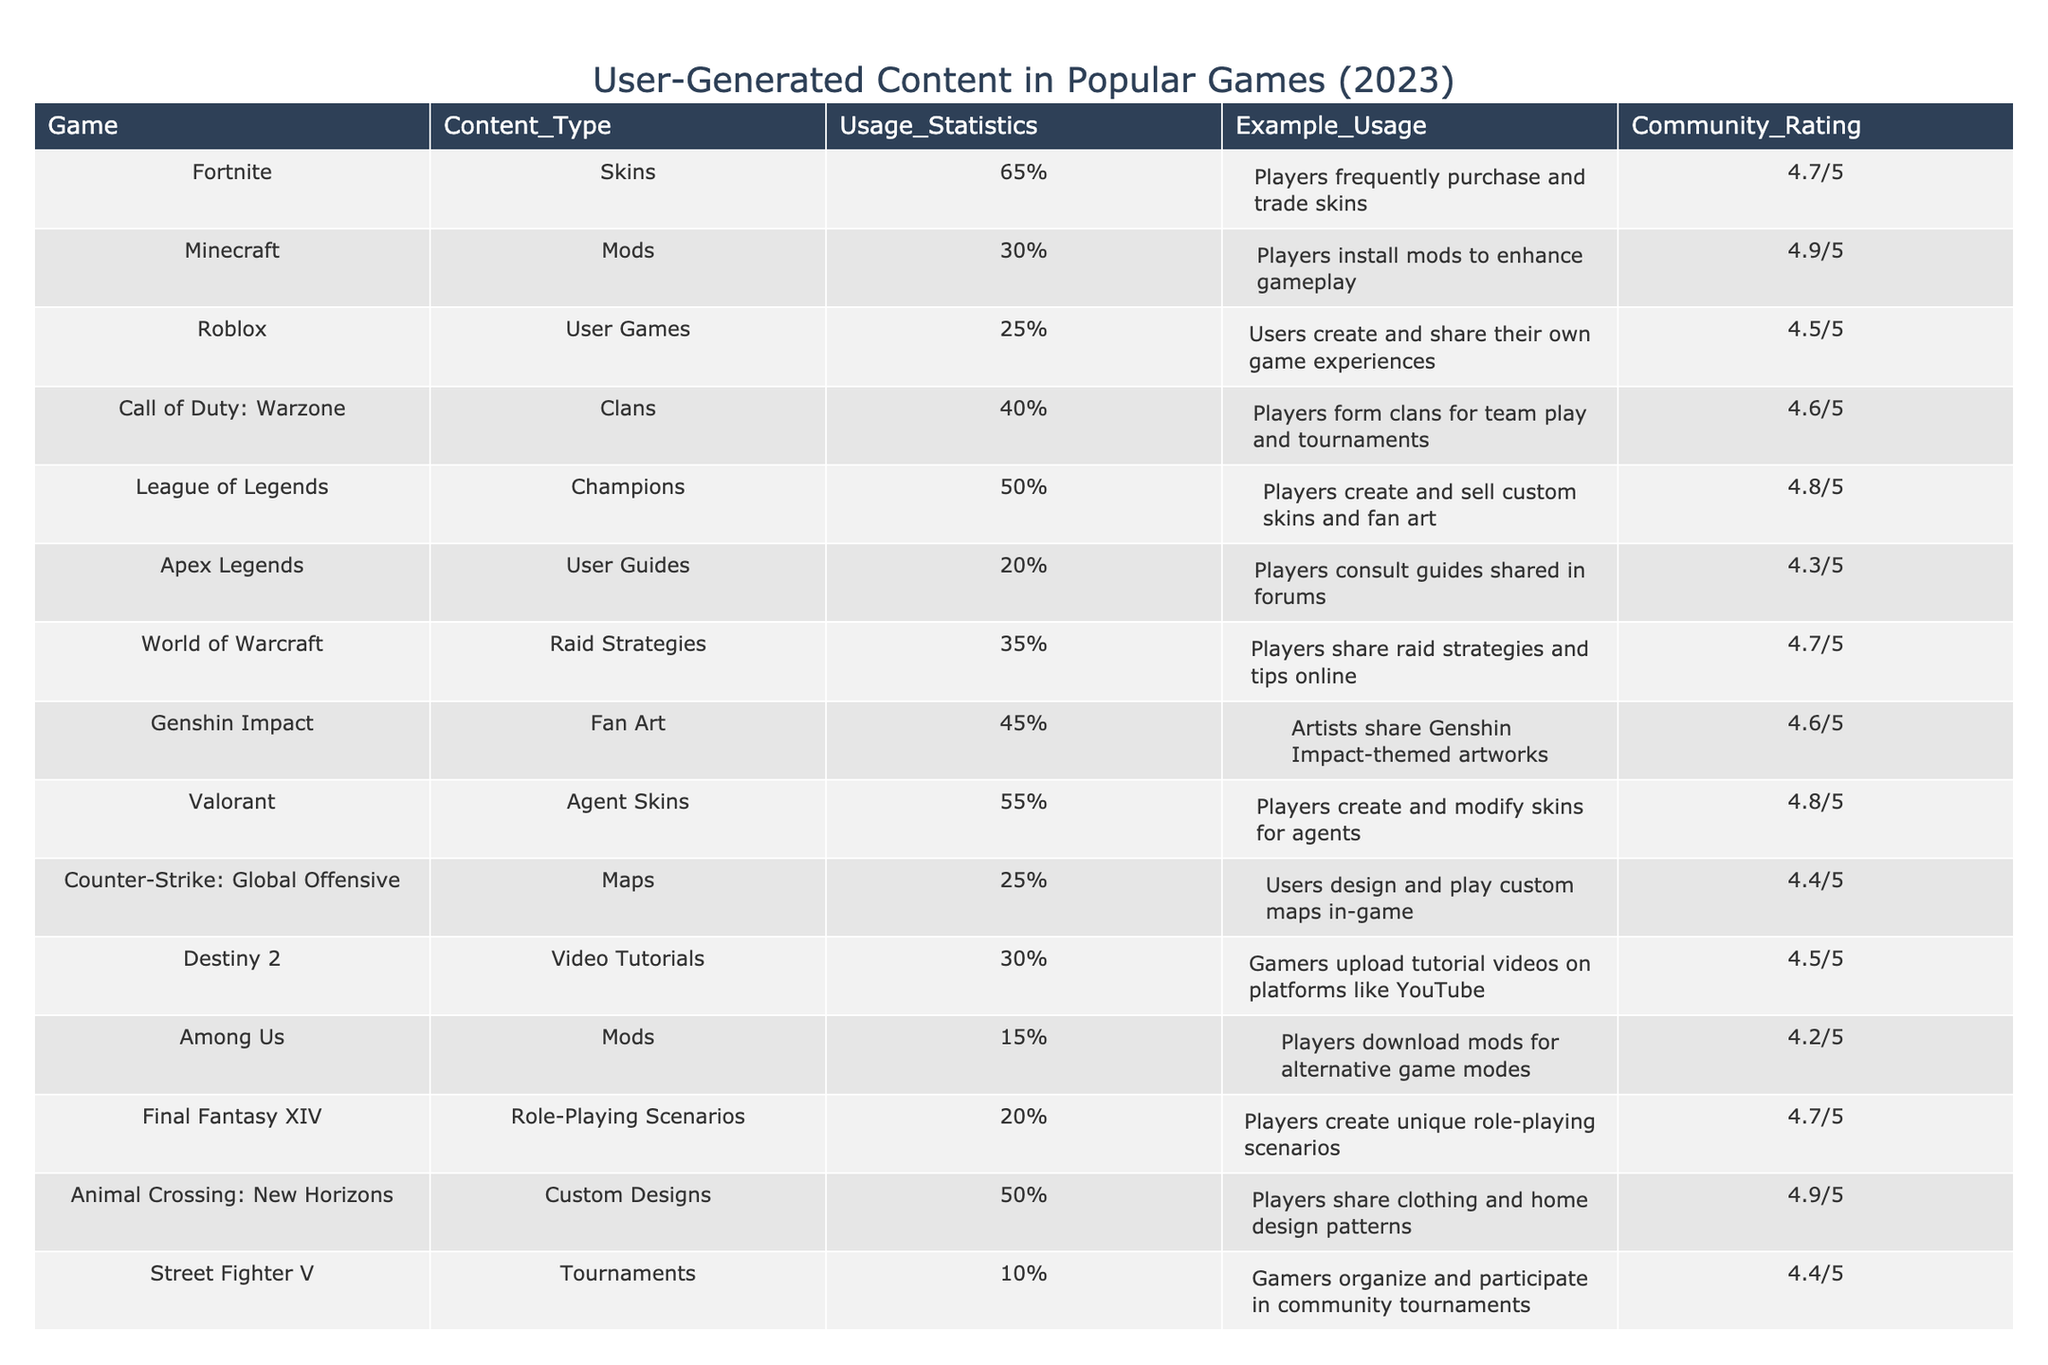What is the community rating for Animal Crossing: New Horizons? The table lists the community rating for Animal Crossing: New Horizons as 4.9/5 in the Community Rating column.
Answer: 4.9/5 Which game has the highest usage statistics for user-generated content? By comparing the Usage Statistics values, Fortnite has the highest usage at 65%.
Answer: Fortnite How many games have a community rating of 4.6 or higher? The community ratings of the games are 4.7, 4.9, 4.5, 4.8, 4.6, 4.7, and 4.4. Counting the ratings, there are 8 games with a rating of 4.6 or higher.
Answer: 8 What is the average usage statistics for games with community ratings below 4.5? The games with ratings below 4.5 are Apex Legends (20%), Among Us (15%), and Street Fighter V (10%). Their usage statistics sum up to 45%, and there are 3 games, so the average is 45% / 3 = 15%.
Answer: 15% Are there any games in the table that have mods as a content type? By scanning the Content_Type column, both Minecraft and Among Us have "Mods" listed as their content type.
Answer: Yes Which game has the lowest usage statistics, and what is that value? The lowest usage statistics is found in Street Fighter V, which has a usage statistics value of 10%.
Answer: 10% What is the difference in usage statistics between Valorant and Call of Duty: Warzone? Valorant has usage statistics of 55%, while Call of Duty: Warzone has 40%. The difference is calculated as 55% - 40% = 15%.
Answer: 15% How many games have user-generated content types related to art? The games related to art are Genshin Impact (Fan Art) and League of Legends (Champions). Counting these, there are 2 games.
Answer: 2 What is the combined usage statistics for games that focus on guides or tutorials? The games that focus on guides or tutorials are Apex Legends (20%), Destiny 2 (30%), and Roblox (25%). The combined usage statistics are calculated as 20% + 30% + 25% = 75%.
Answer: 75% 